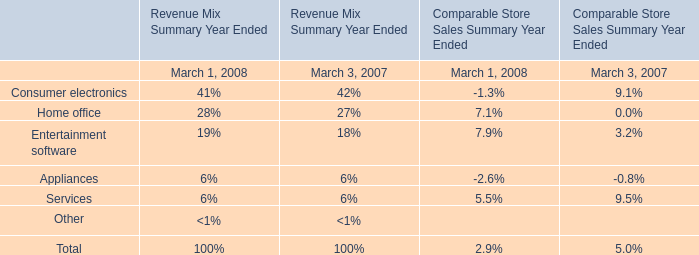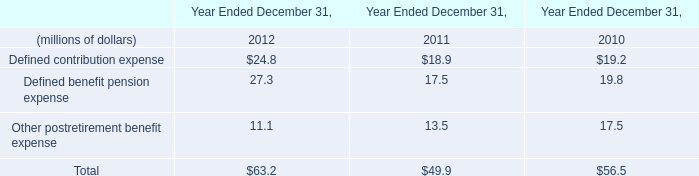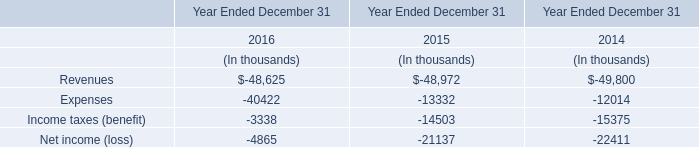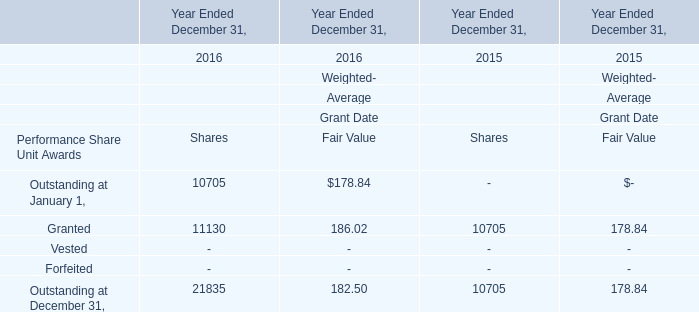As As the chart 3 shows,which year Ended December 31 is Weighted-Average Grant Date Fair Value for Granted the highest? 
Answer: 2016. 